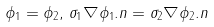<formula> <loc_0><loc_0><loc_500><loc_500>\phi _ { 1 } = \phi _ { 2 } , \, \sigma _ { 1 } \nabla \phi _ { 1 } . { n } = \sigma _ { 2 } \nabla \phi _ { 2 } . { n }</formula> 